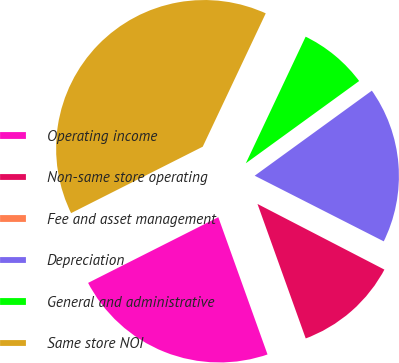<chart> <loc_0><loc_0><loc_500><loc_500><pie_chart><fcel>Operating income<fcel>Non-same store operating<fcel>Fee and asset management<fcel>Depreciation<fcel>General and administrative<fcel>Same store NOI<nl><fcel>23.04%<fcel>11.92%<fcel>0.11%<fcel>17.48%<fcel>7.98%<fcel>39.46%<nl></chart> 